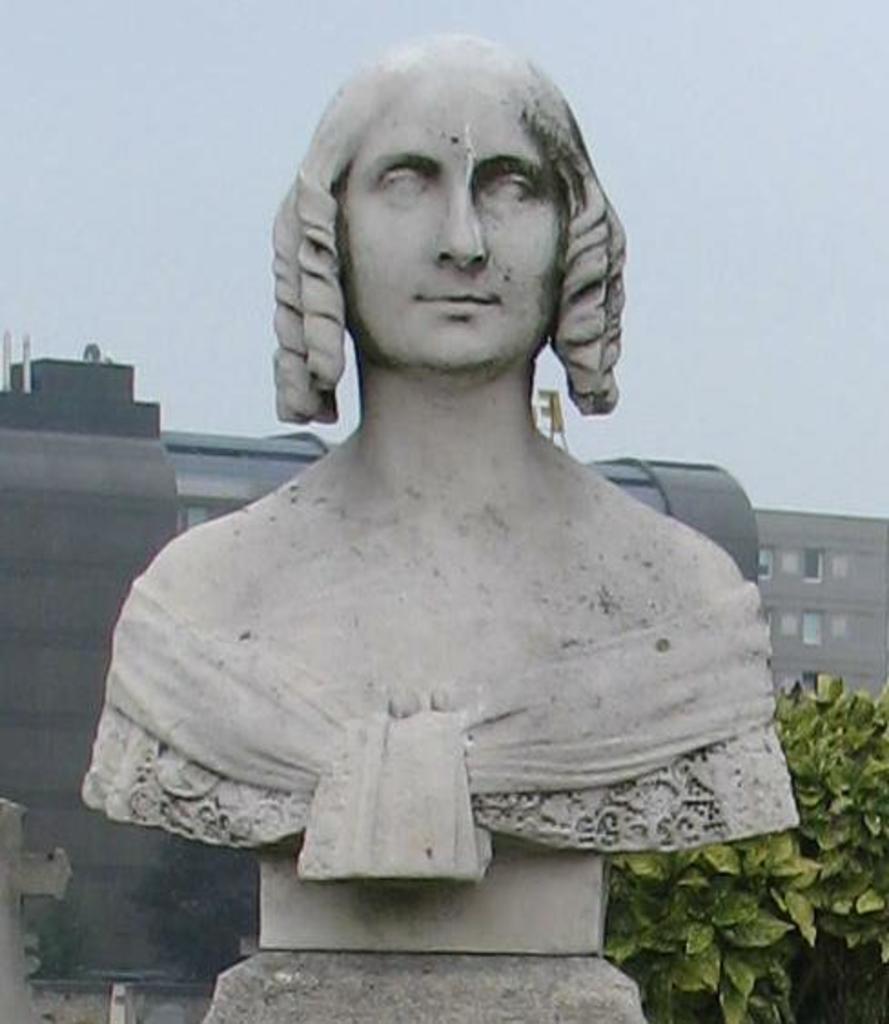In one or two sentences, can you explain what this image depicts? In the foreground of this image, there is a statue. On the left, there is a cross symbol. On the right, there are plants. In the background, it seems like buildings and the sky at the top. 